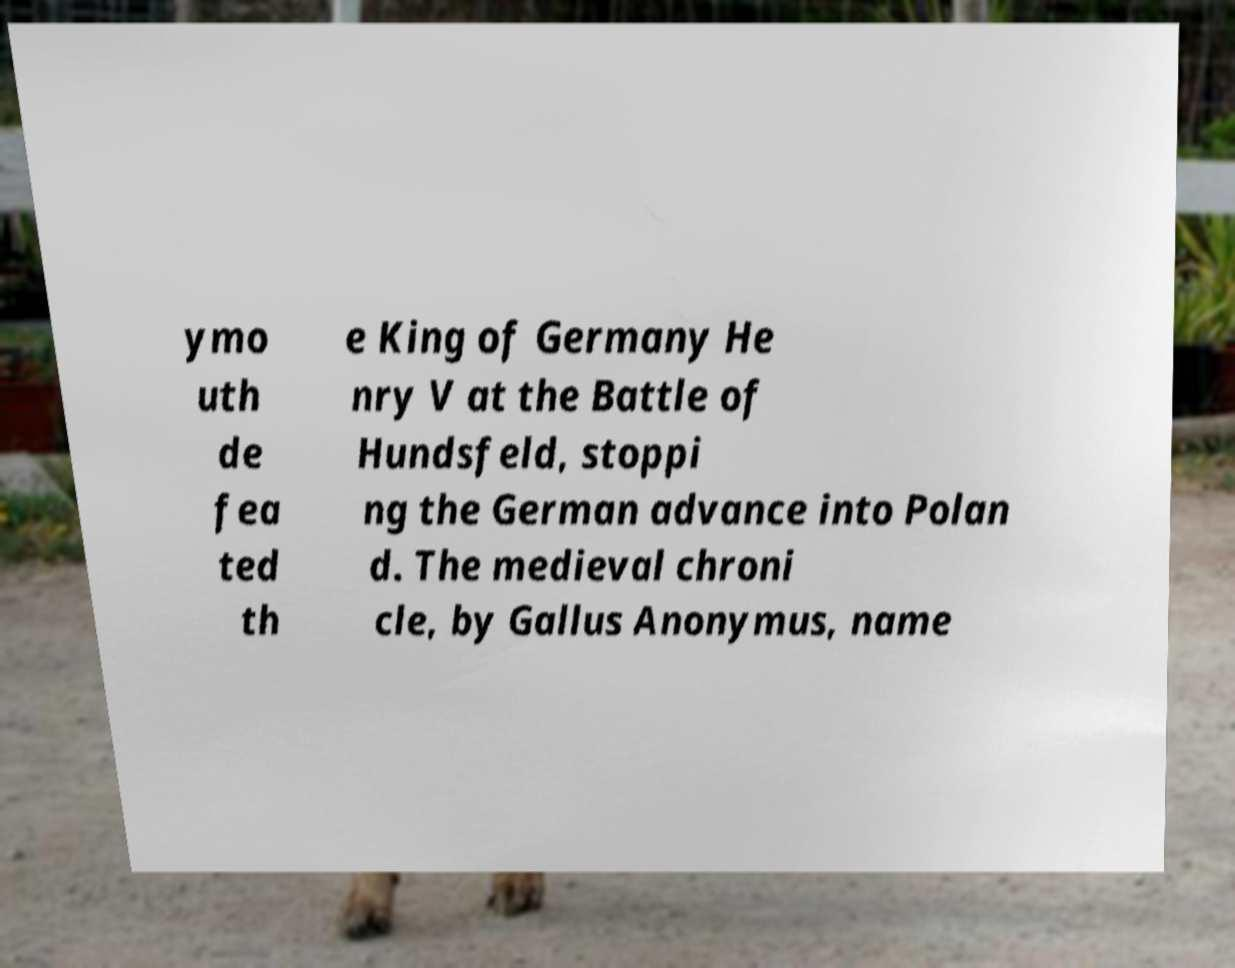Please read and relay the text visible in this image. What does it say? ymo uth de fea ted th e King of Germany He nry V at the Battle of Hundsfeld, stoppi ng the German advance into Polan d. The medieval chroni cle, by Gallus Anonymus, name 